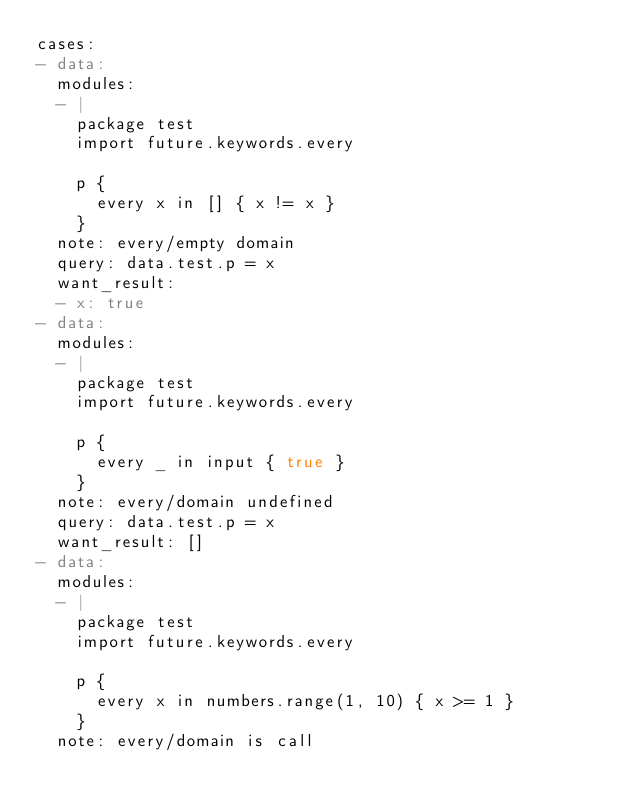<code> <loc_0><loc_0><loc_500><loc_500><_YAML_>cases:
- data:
  modules:
  - |
    package test
    import future.keywords.every

    p {
      every x in [] { x != x }
    }
  note: every/empty domain
  query: data.test.p = x
  want_result:
  - x: true
- data:
  modules:
  - |
    package test
    import future.keywords.every

    p {
      every _ in input { true }
    }
  note: every/domain undefined
  query: data.test.p = x
  want_result: []
- data:
  modules:
  - |
    package test
    import future.keywords.every

    p {
      every x in numbers.range(1, 10) { x >= 1 }
    }
  note: every/domain is call</code> 